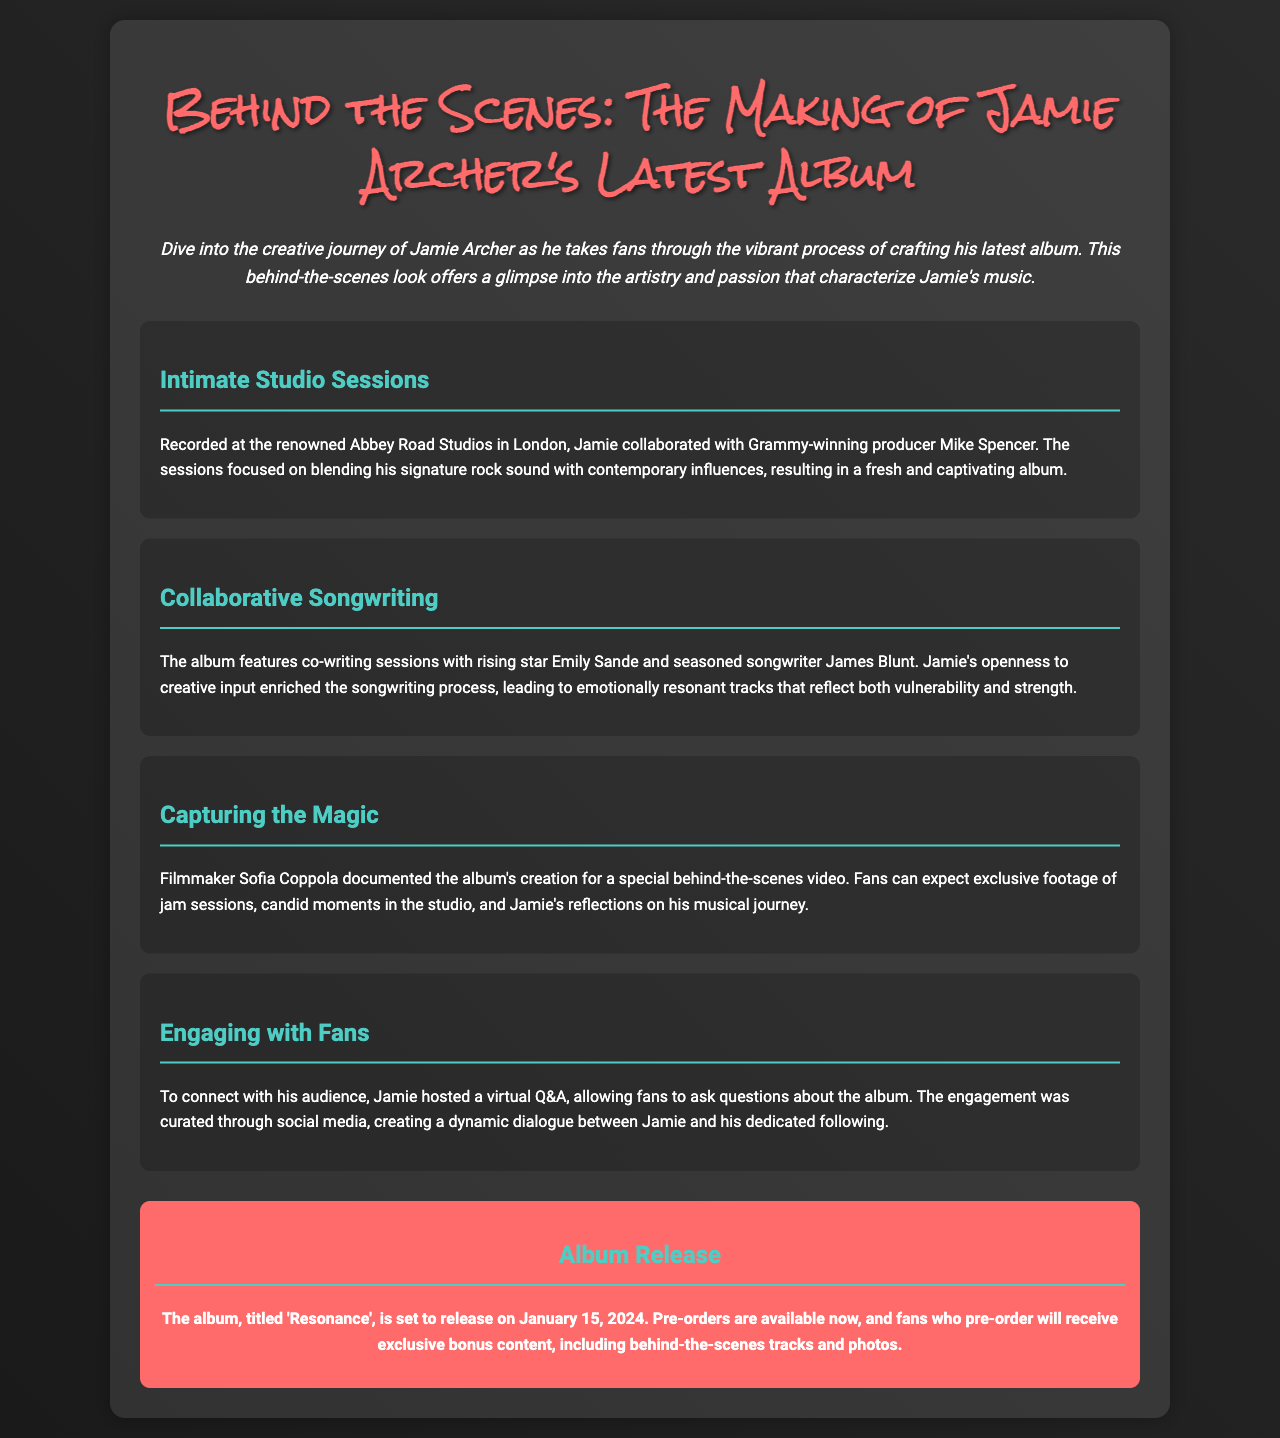What is the name of the album? The name of the album is mentioned in the release section of the document.
Answer: Resonance Who produced the album? The producer's name is mentioned in the section about studio sessions.
Answer: Mike Spencer When is the album set to release? The release date is clearly stated in the release info section.
Answer: January 15, 2024 Which studio was used for recording? The section on intimate studio sessions specifies where the recording took place.
Answer: Abbey Road Studios Who collaborated with Jamie on songwriting? The document lists the collaborators in the section about songwriting.
Answer: Emily Sande and James Blunt What type of video is being made about the album? The document describes the nature of the video in the capturing the magic section.
Answer: Behind-the-scenes video How did Jamie engage with fans? The method of engagement is explained in the section on fan engagement.
Answer: Virtual Q&A What is one of the features of pre-ordering the album? The information about pre-ordering mentions exclusive content.
Answer: Exclusive bonus content 